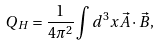<formula> <loc_0><loc_0><loc_500><loc_500>Q _ { H } = \frac { 1 } { 4 \pi ^ { 2 } } \int d ^ { 3 } x \vec { A } \cdot \vec { B } ,</formula> 